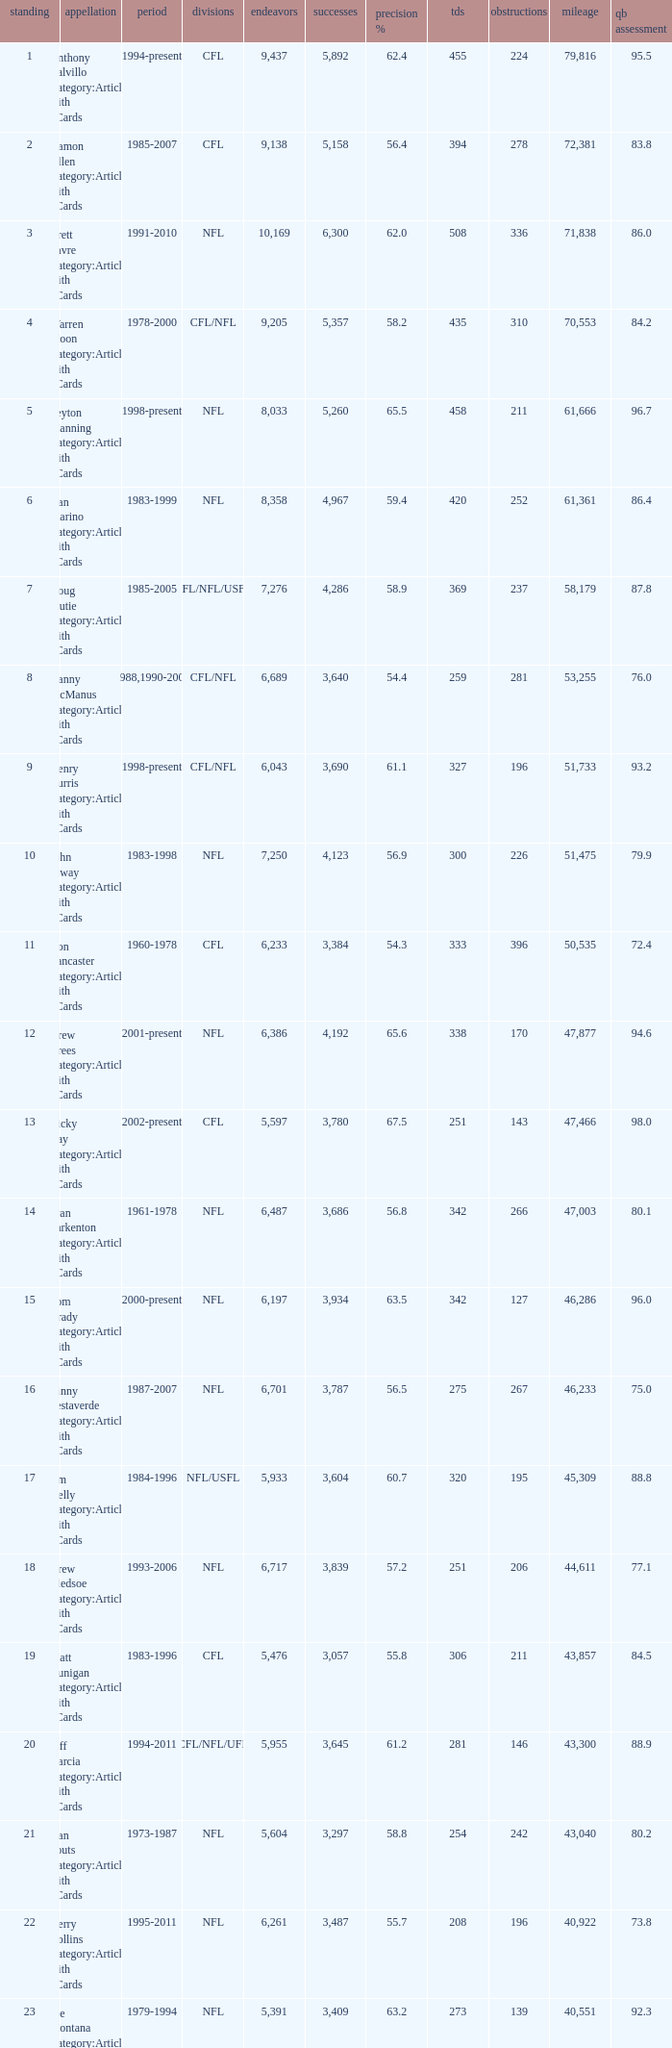I'm looking to parse the entire table for insights. Could you assist me with that? {'header': ['standing', 'appellation', 'period', 'divisions', 'endeavors', 'successes', 'precision %', 'tds', 'obstructions', 'mileage', 'qb assessment'], 'rows': [['1', 'Anthony Calvillo Category:Articles with hCards', '1994-present', 'CFL', '9,437', '5,892', '62.4', '455', '224', '79,816', '95.5'], ['2', 'Damon Allen Category:Articles with hCards', '1985-2007', 'CFL', '9,138', '5,158', '56.4', '394', '278', '72,381', '83.8'], ['3', 'Brett Favre Category:Articles with hCards', '1991-2010', 'NFL', '10,169', '6,300', '62.0', '508', '336', '71,838', '86.0'], ['4', 'Warren Moon Category:Articles with hCards', '1978-2000', 'CFL/NFL', '9,205', '5,357', '58.2', '435', '310', '70,553', '84.2'], ['5', 'Peyton Manning Category:Articles with hCards', '1998-present', 'NFL', '8,033', '5,260', '65.5', '458', '211', '61,666', '96.7'], ['6', 'Dan Marino Category:Articles with hCards', '1983-1999', 'NFL', '8,358', '4,967', '59.4', '420', '252', '61,361', '86.4'], ['7', 'Doug Flutie Category:Articles with hCards', '1985-2005', 'CFL/NFL/USFL', '7,276', '4,286', '58.9', '369', '237', '58,179', '87.8'], ['8', 'Danny McManus Category:Articles with hCards', '1988,1990-2006', 'CFL/NFL', '6,689', '3,640', '54.4', '259', '281', '53,255', '76.0'], ['9', 'Henry Burris Category:Articles with hCards', '1998-present', 'CFL/NFL', '6,043', '3,690', '61.1', '327', '196', '51,733', '93.2'], ['10', 'John Elway Category:Articles with hCards', '1983-1998', 'NFL', '7,250', '4,123', '56.9', '300', '226', '51,475', '79.9'], ['11', 'Ron Lancaster Category:Articles with hCards', '1960-1978', 'CFL', '6,233', '3,384', '54.3', '333', '396', '50,535', '72.4'], ['12', 'Drew Brees Category:Articles with hCards', '2001-present', 'NFL', '6,386', '4,192', '65.6', '338', '170', '47,877', '94.6'], ['13', 'Ricky Ray Category:Articles with hCards', '2002-present', 'CFL', '5,597', '3,780', '67.5', '251', '143', '47,466', '98.0'], ['14', 'Fran Tarkenton Category:Articles with hCards', '1961-1978', 'NFL', '6,487', '3,686', '56.8', '342', '266', '47,003', '80.1'], ['15', 'Tom Brady Category:Articles with hCards', '2000-present', 'NFL', '6,197', '3,934', '63.5', '342', '127', '46,286', '96.0'], ['16', 'Vinny Testaverde Category:Articles with hCards', '1987-2007', 'NFL', '6,701', '3,787', '56.5', '275', '267', '46,233', '75.0'], ['17', 'Jim Kelly Category:Articles with hCards', '1984-1996', 'NFL/USFL', '5,933', '3,604', '60.7', '320', '195', '45,309', '88.8'], ['18', 'Drew Bledsoe Category:Articles with hCards', '1993-2006', 'NFL', '6,717', '3,839', '57.2', '251', '206', '44,611', '77.1'], ['19', 'Matt Dunigan Category:Articles with hCards', '1983-1996', 'CFL', '5,476', '3,057', '55.8', '306', '211', '43,857', '84.5'], ['20', 'Jeff Garcia Category:Articles with hCards', '1994-2011', 'CFL/NFL/UFL', '5,955', '3,645', '61.2', '281', '146', '43,300', '88.9'], ['21', 'Dan Fouts Category:Articles with hCards', '1973-1987', 'NFL', '5,604', '3,297', '58.8', '254', '242', '43,040', '80.2'], ['22', 'Kerry Collins Category:Articles with hCards', '1995-2011', 'NFL', '6,261', '3,487', '55.7', '208', '196', '40,922', '73.8'], ['23', 'Joe Montana Category:Articles with hCards', '1979-1994', 'NFL', '5,391', '3,409', '63.2', '273', '139', '40,551', '92.3'], ['24', 'Tracy Ham Category:Articles with hCards', '1987-1999', 'CFL', '4,945', '2,670', '54.0', '284', '164', '40,534', '86.6'], ['25', 'Johnny Unitas Category:Articles with hCards', '1956-1973', 'NFL', '5,186', '2,830', '54.6', '290', '253', '40,239', '78.2']]} What is the comp percentage when there are less than 44,611 in yardage, more than 254 touchdowns, and rank larger than 24? 54.6. 